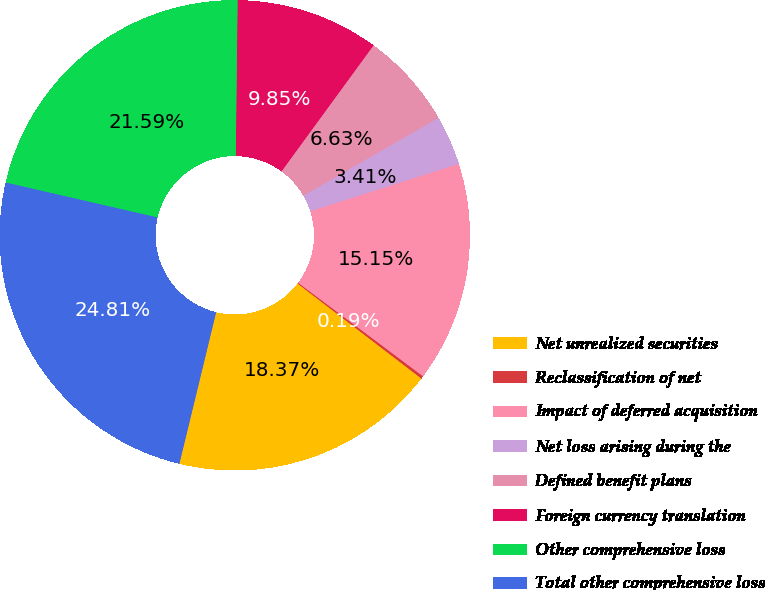Convert chart. <chart><loc_0><loc_0><loc_500><loc_500><pie_chart><fcel>Net unrealized securities<fcel>Reclassification of net<fcel>Impact of deferred acquisition<fcel>Net loss arising during the<fcel>Defined benefit plans<fcel>Foreign currency translation<fcel>Other comprehensive loss<fcel>Total other comprehensive loss<nl><fcel>18.37%<fcel>0.19%<fcel>15.15%<fcel>3.41%<fcel>6.63%<fcel>9.85%<fcel>21.59%<fcel>24.81%<nl></chart> 